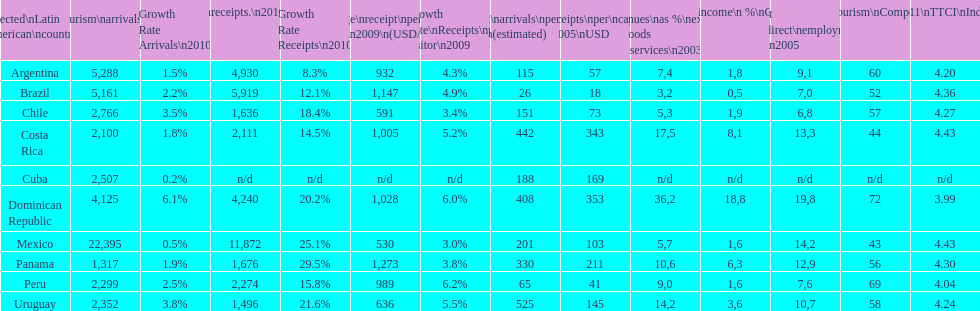What is the name of the country that had the most international tourism arrivals in 2010? Mexico. 